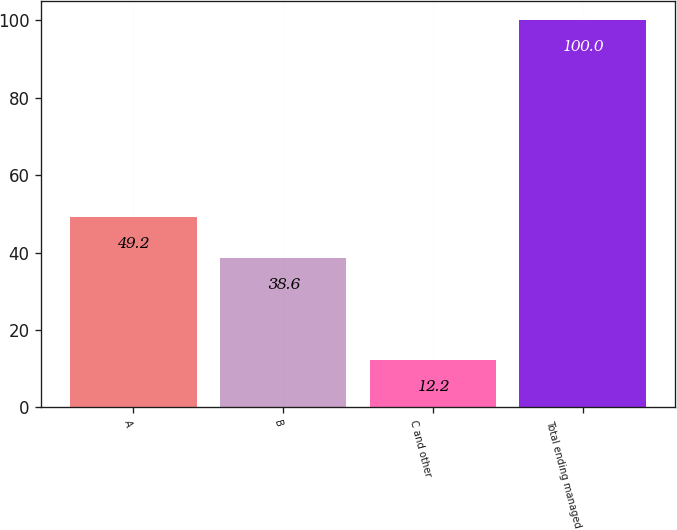Convert chart to OTSL. <chart><loc_0><loc_0><loc_500><loc_500><bar_chart><fcel>A<fcel>B<fcel>C and other<fcel>Total ending managed<nl><fcel>49.2<fcel>38.6<fcel>12.2<fcel>100<nl></chart> 